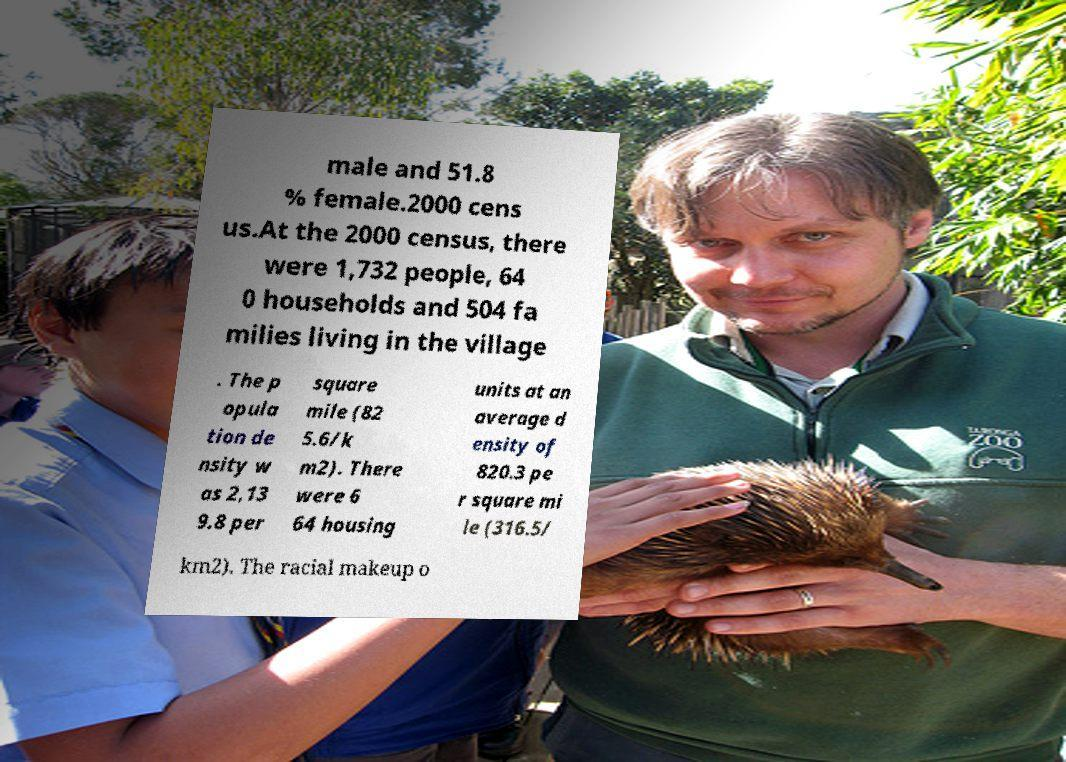What messages or text are displayed in this image? I need them in a readable, typed format. male and 51.8 % female.2000 cens us.At the 2000 census, there were 1,732 people, 64 0 households and 504 fa milies living in the village . The p opula tion de nsity w as 2,13 9.8 per square mile (82 5.6/k m2). There were 6 64 housing units at an average d ensity of 820.3 pe r square mi le (316.5/ km2). The racial makeup o 